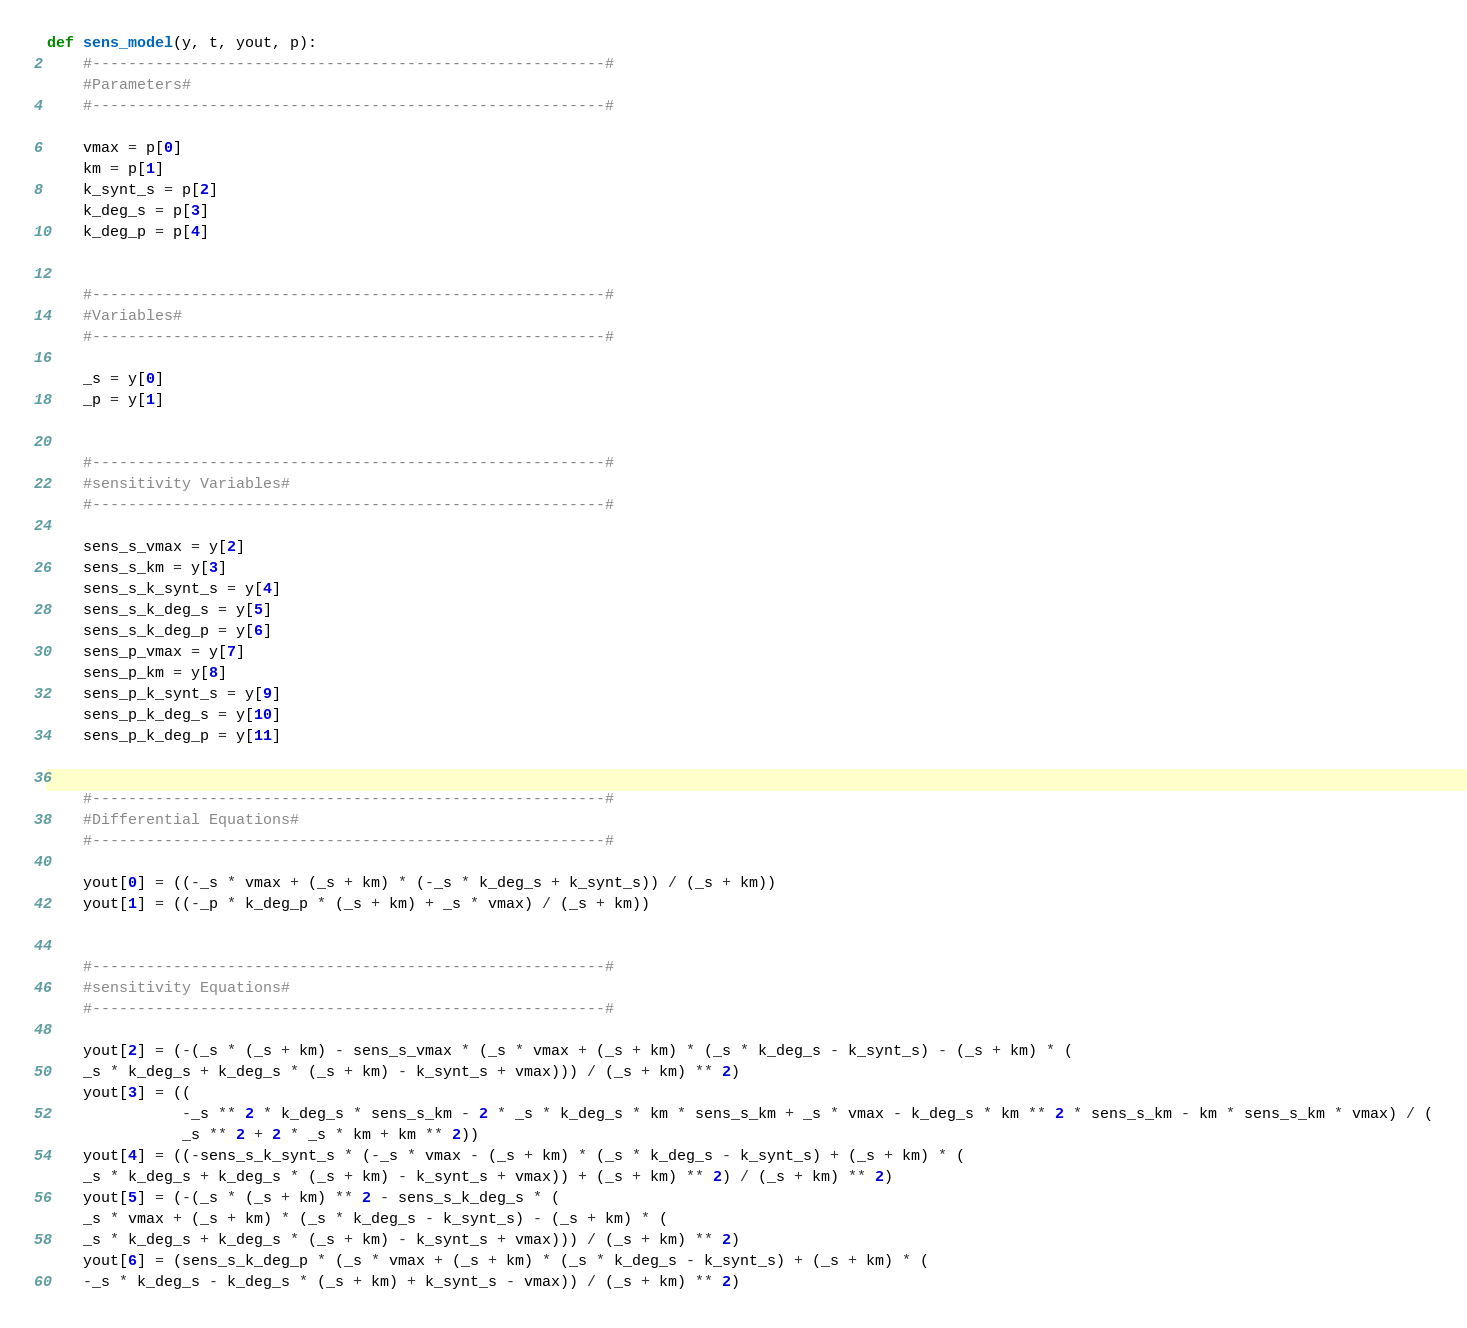<code> <loc_0><loc_0><loc_500><loc_500><_Python_>def sens_model(y, t, yout, p):
    #---------------------------------------------------------#
    #Parameters#
    #---------------------------------------------------------#

    vmax = p[0]
    km = p[1]
    k_synt_s = p[2]
    k_deg_s = p[3]
    k_deg_p = p[4]


    #---------------------------------------------------------#
    #Variables#
    #---------------------------------------------------------#

    _s = y[0]
    _p = y[1]


    #---------------------------------------------------------#
    #sensitivity Variables#
    #---------------------------------------------------------#

    sens_s_vmax = y[2]
    sens_s_km = y[3]
    sens_s_k_synt_s = y[4]
    sens_s_k_deg_s = y[5]
    sens_s_k_deg_p = y[6]
    sens_p_vmax = y[7]
    sens_p_km = y[8]
    sens_p_k_synt_s = y[9]
    sens_p_k_deg_s = y[10]
    sens_p_k_deg_p = y[11]


    #---------------------------------------------------------#
    #Differential Equations#
    #---------------------------------------------------------#

    yout[0] = ((-_s * vmax + (_s + km) * (-_s * k_deg_s + k_synt_s)) / (_s + km))
    yout[1] = ((-_p * k_deg_p * (_s + km) + _s * vmax) / (_s + km))


    #---------------------------------------------------------#
    #sensitivity Equations#
    #---------------------------------------------------------#

    yout[2] = (-(_s * (_s + km) - sens_s_vmax * (_s * vmax + (_s + km) * (_s * k_deg_s - k_synt_s) - (_s + km) * (
    _s * k_deg_s + k_deg_s * (_s + km) - k_synt_s + vmax))) / (_s + km) ** 2)
    yout[3] = ((
               -_s ** 2 * k_deg_s * sens_s_km - 2 * _s * k_deg_s * km * sens_s_km + _s * vmax - k_deg_s * km ** 2 * sens_s_km - km * sens_s_km * vmax) / (
               _s ** 2 + 2 * _s * km + km ** 2))
    yout[4] = ((-sens_s_k_synt_s * (-_s * vmax - (_s + km) * (_s * k_deg_s - k_synt_s) + (_s + km) * (
    _s * k_deg_s + k_deg_s * (_s + km) - k_synt_s + vmax)) + (_s + km) ** 2) / (_s + km) ** 2)
    yout[5] = (-(_s * (_s + km) ** 2 - sens_s_k_deg_s * (
    _s * vmax + (_s + km) * (_s * k_deg_s - k_synt_s) - (_s + km) * (
    _s * k_deg_s + k_deg_s * (_s + km) - k_synt_s + vmax))) / (_s + km) ** 2)
    yout[6] = (sens_s_k_deg_p * (_s * vmax + (_s + km) * (_s * k_deg_s - k_synt_s) + (_s + km) * (
    -_s * k_deg_s - k_deg_s * (_s + km) + k_synt_s - vmax)) / (_s + km) ** 2)</code> 